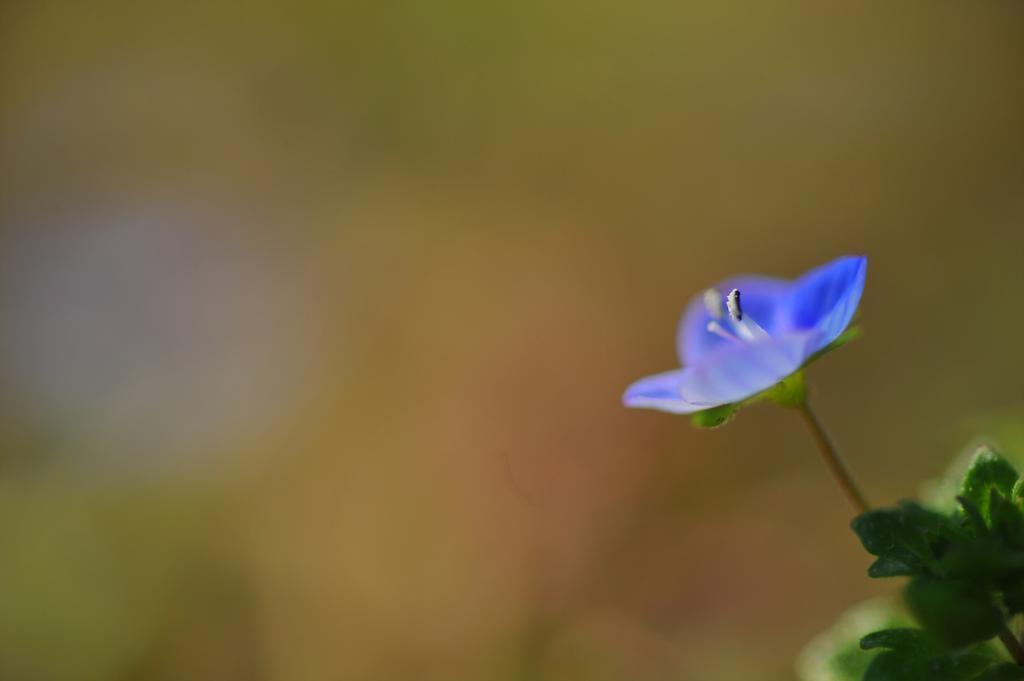Can you describe this image briefly? In this picture we can see a violet flower and a few green leaves on the right side. Background is blurry. 